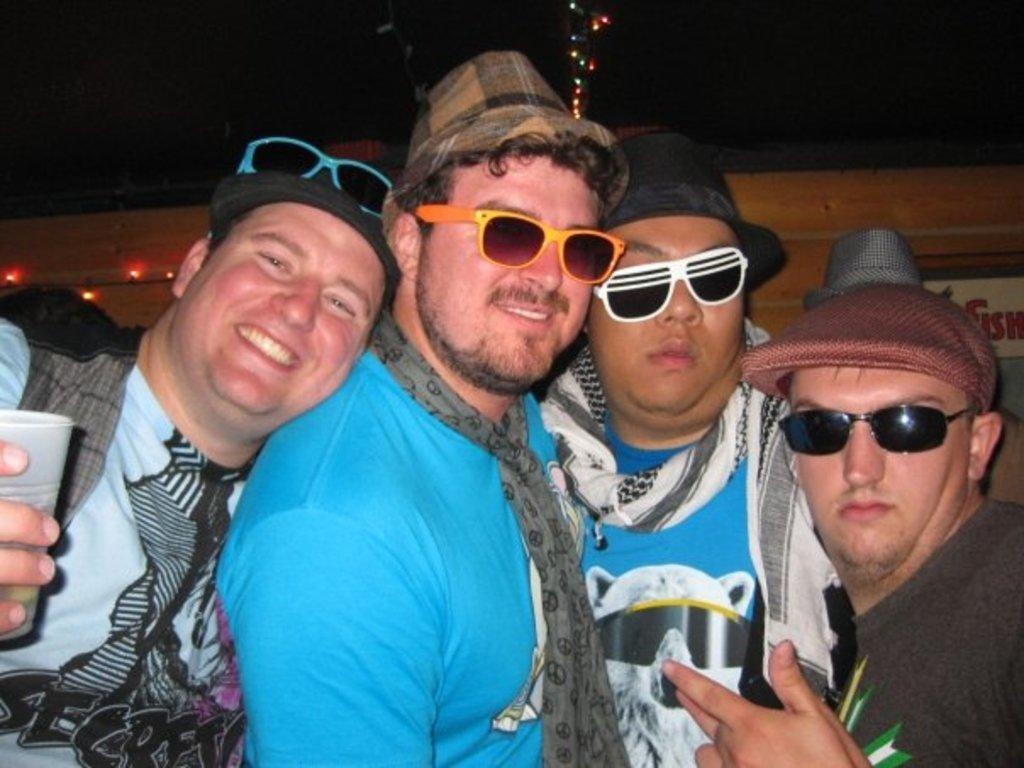Please provide a concise description of this image. In the image we can see there are people standing and there are three men wearing hats and sunglasses. There is a man holding glass in his hand and behind there are lights on the top. 